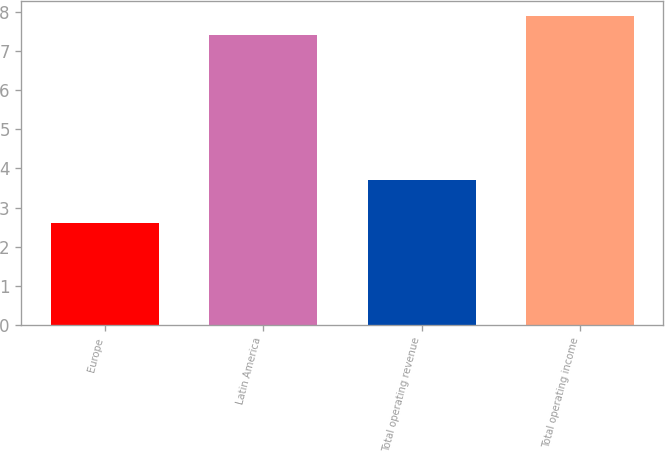Convert chart to OTSL. <chart><loc_0><loc_0><loc_500><loc_500><bar_chart><fcel>Europe<fcel>Latin America<fcel>Total operating revenue<fcel>Total operating income<nl><fcel>2.6<fcel>7.4<fcel>3.7<fcel>7.89<nl></chart> 